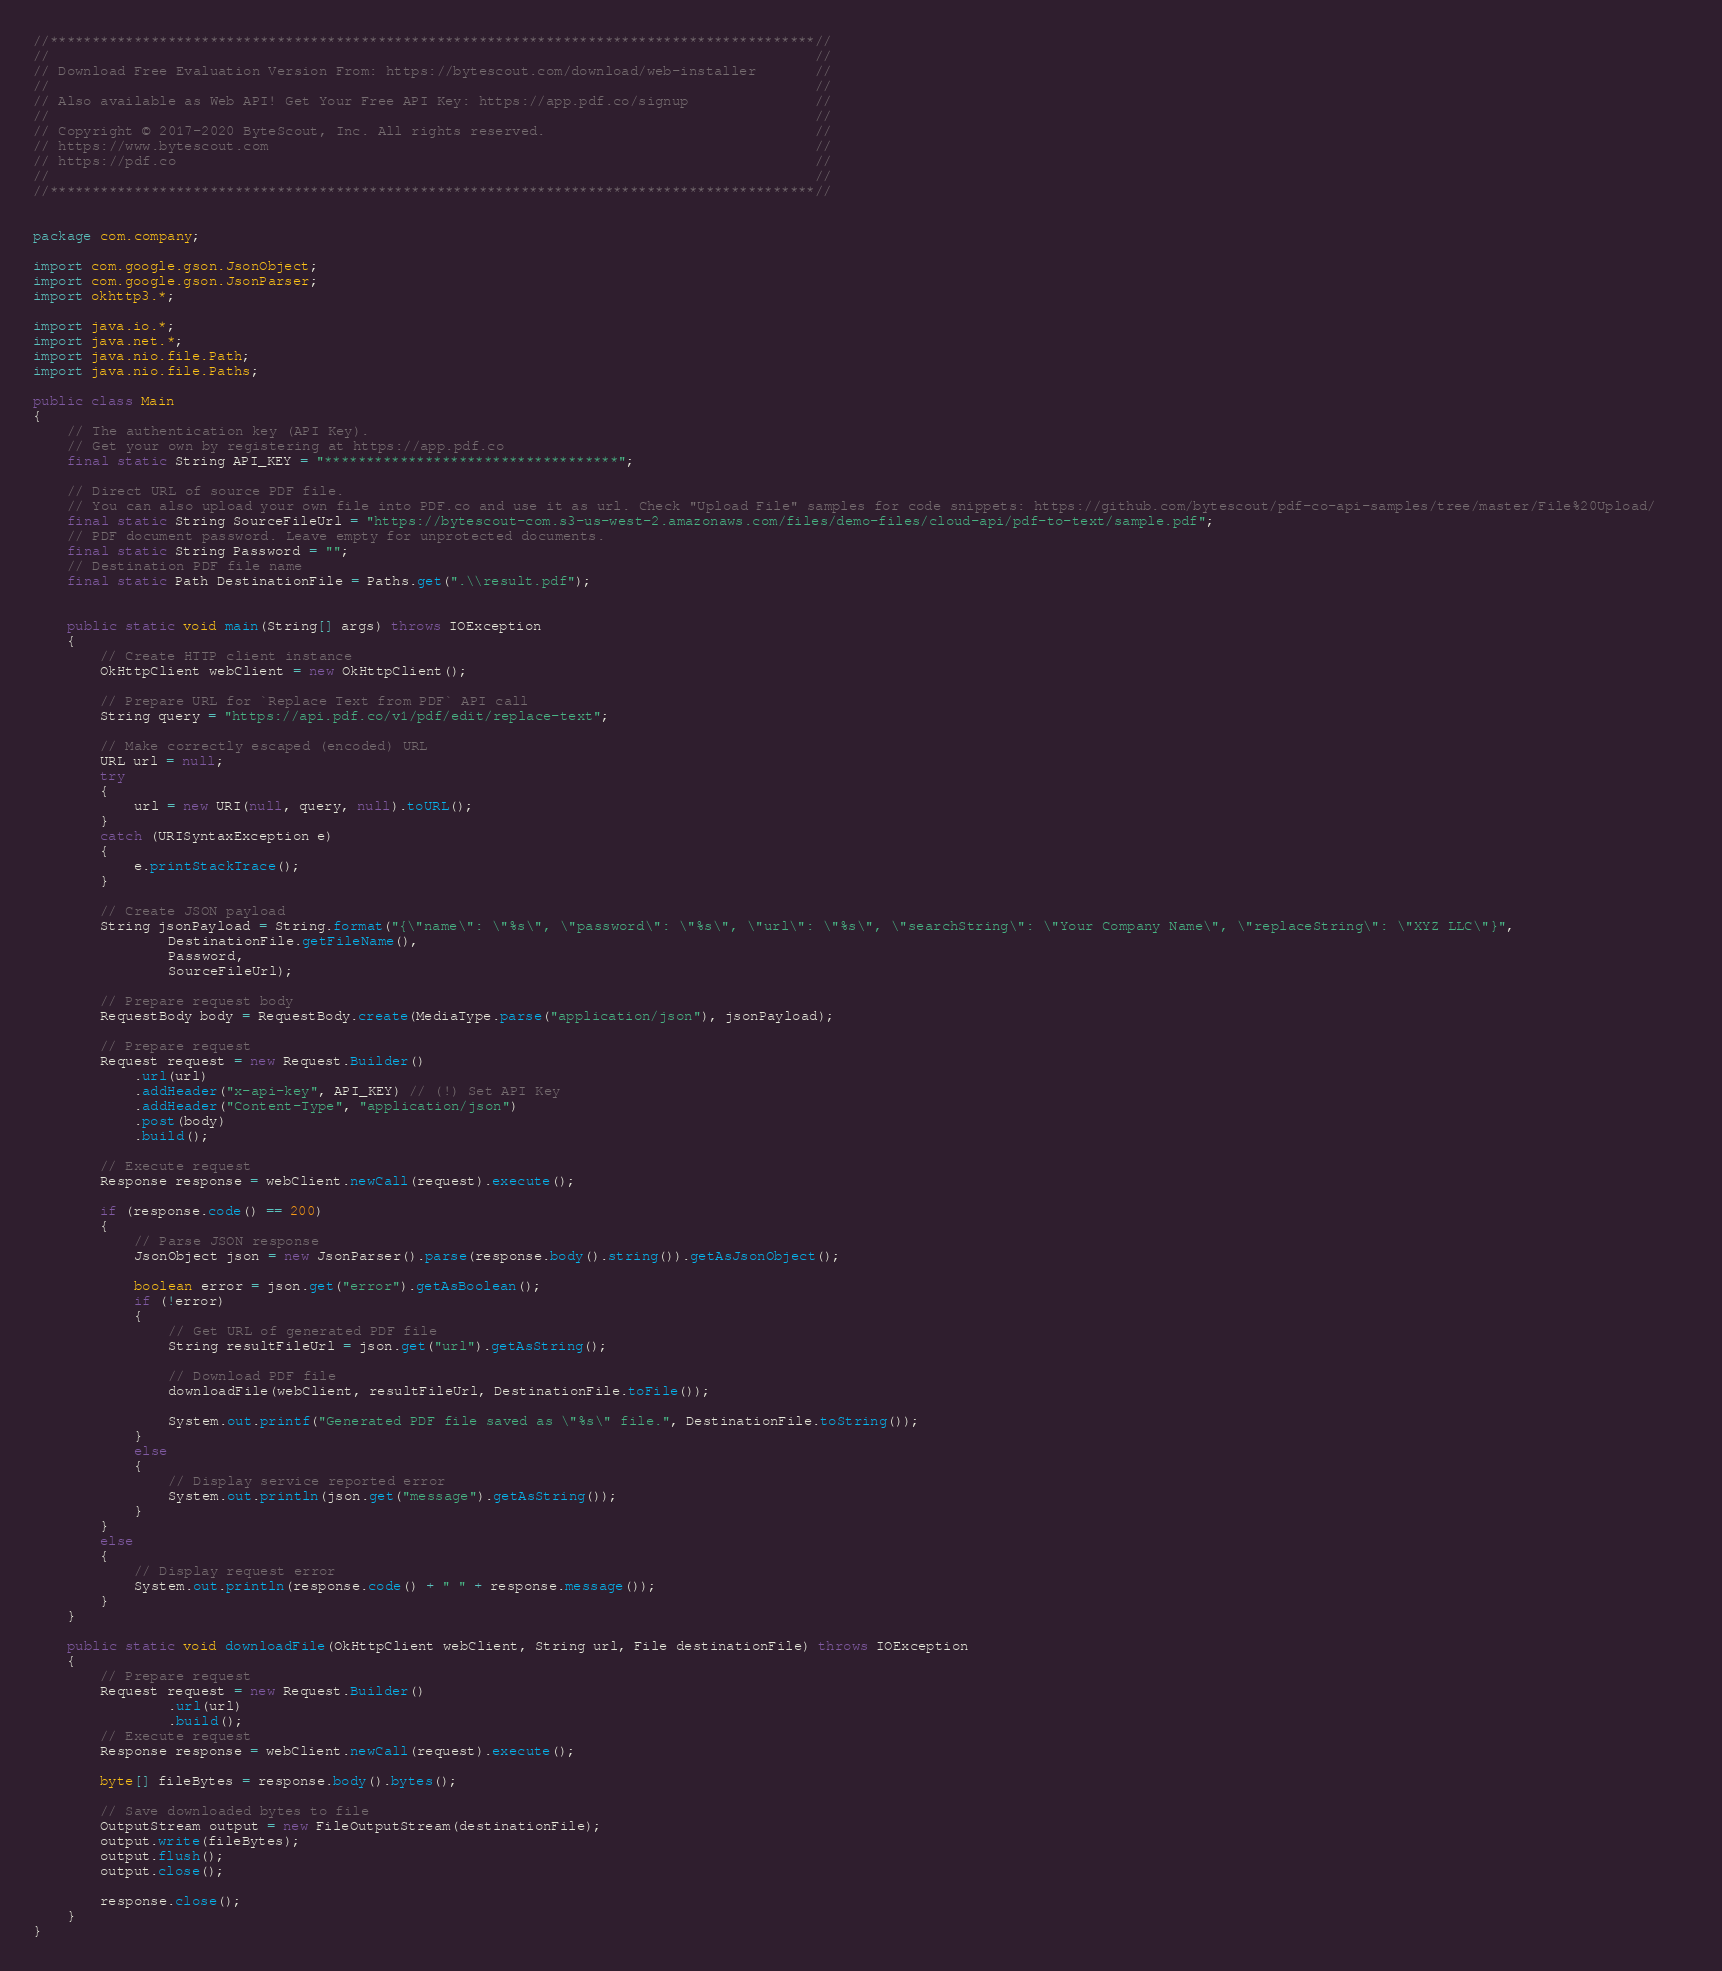Convert code to text. <code><loc_0><loc_0><loc_500><loc_500><_Java_>//*******************************************************************************************//
//                                                                                           //
// Download Free Evaluation Version From: https://bytescout.com/download/web-installer       //
//                                                                                           //
// Also available as Web API! Get Your Free API Key: https://app.pdf.co/signup               //
//                                                                                           //
// Copyright © 2017-2020 ByteScout, Inc. All rights reserved.                                //
// https://www.bytescout.com                                                                 //
// https://pdf.co                                                                            //
//                                                                                           //
//*******************************************************************************************//


package com.company;

import com.google.gson.JsonObject;
import com.google.gson.JsonParser;
import okhttp3.*;

import java.io.*;
import java.net.*;
import java.nio.file.Path;
import java.nio.file.Paths;

public class Main
{
    // The authentication key (API Key).
    // Get your own by registering at https://app.pdf.co
    final static String API_KEY = "***********************************";

    // Direct URL of source PDF file.
    // You can also upload your own file into PDF.co and use it as url. Check "Upload File" samples for code snippets: https://github.com/bytescout/pdf-co-api-samples/tree/master/File%20Upload/    
    final static String SourceFileUrl = "https://bytescout-com.s3-us-west-2.amazonaws.com/files/demo-files/cloud-api/pdf-to-text/sample.pdf";
    // PDF document password. Leave empty for unprotected documents.
    final static String Password = "";
    // Destination PDF file name
    final static Path DestinationFile = Paths.get(".\\result.pdf");


    public static void main(String[] args) throws IOException
    {
        // Create HTTP client instance
        OkHttpClient webClient = new OkHttpClient();

        // Prepare URL for `Replace Text from PDF` API call
        String query = "https://api.pdf.co/v1/pdf/edit/replace-text";

        // Make correctly escaped (encoded) URL
        URL url = null;
        try
        {
            url = new URI(null, query, null).toURL();
        }
        catch (URISyntaxException e)
        {
            e.printStackTrace();
        }

        // Create JSON payload
		String jsonPayload = String.format("{\"name\": \"%s\", \"password\": \"%s\", \"url\": \"%s\", \"searchString\": \"Your Company Name\", \"replaceString\": \"XYZ LLC\"}",
                DestinationFile.getFileName(),
                Password,
                SourceFileUrl);

        // Prepare request body
        RequestBody body = RequestBody.create(MediaType.parse("application/json"), jsonPayload);
        
        // Prepare request
        Request request = new Request.Builder()
            .url(url)
            .addHeader("x-api-key", API_KEY) // (!) Set API Key
            .addHeader("Content-Type", "application/json")
            .post(body)
            .build();
        
        // Execute request
        Response response = webClient.newCall(request).execute();
        
        if (response.code() == 200)
        {
            // Parse JSON response
            JsonObject json = new JsonParser().parse(response.body().string()).getAsJsonObject();

            boolean error = json.get("error").getAsBoolean();
            if (!error)
            {
                // Get URL of generated PDF file
                String resultFileUrl = json.get("url").getAsString();

                // Download PDF file
                downloadFile(webClient, resultFileUrl, DestinationFile.toFile());

                System.out.printf("Generated PDF file saved as \"%s\" file.", DestinationFile.toString());
            }
            else
            {
                // Display service reported error
                System.out.println(json.get("message").getAsString());
            }
        }
        else
        {
            // Display request error
            System.out.println(response.code() + " " + response.message());
        }
    }

    public static void downloadFile(OkHttpClient webClient, String url, File destinationFile) throws IOException
    {
        // Prepare request
        Request request = new Request.Builder()
                .url(url)
                .build();
        // Execute request
        Response response = webClient.newCall(request).execute();

        byte[] fileBytes = response.body().bytes();

        // Save downloaded bytes to file
        OutputStream output = new FileOutputStream(destinationFile);
        output.write(fileBytes);
        output.flush();
        output.close();

        response.close();
    }
}
</code> 